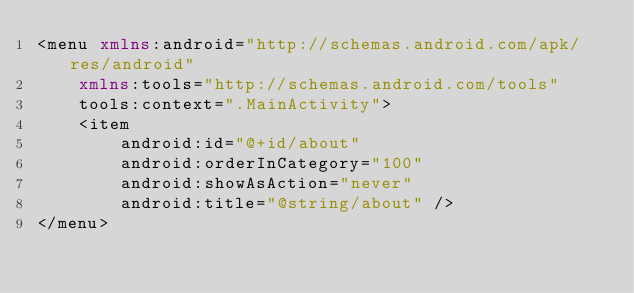Convert code to text. <code><loc_0><loc_0><loc_500><loc_500><_XML_><menu xmlns:android="http://schemas.android.com/apk/res/android"
    xmlns:tools="http://schemas.android.com/tools"
    tools:context=".MainActivity">
    <item
        android:id="@+id/about"
        android:orderInCategory="100"
        android:showAsAction="never"
        android:title="@string/about" />
</menu>
</code> 